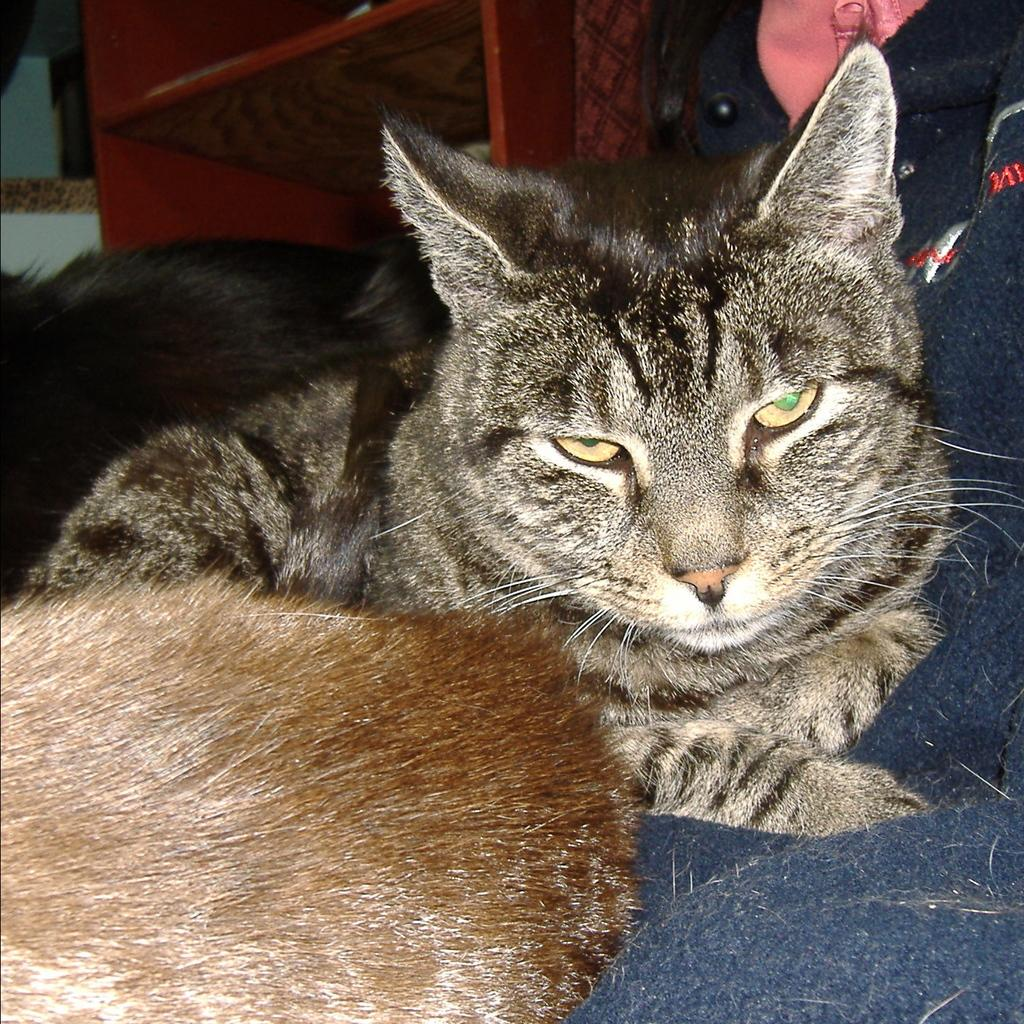What type of animal is the main subject of the image? There is a grey color cat in the image. Are there any other animals visible in the image besides the cat? Yes, there are other animals visible in the image. What type of pie is being served at the organization's event in the image? There is no pie or organization event present in the image; it features a grey color cat and other animals. Can you tell me how many robins are visible in the image? There are no robins present in the image; it features a grey color cat and other animals. 